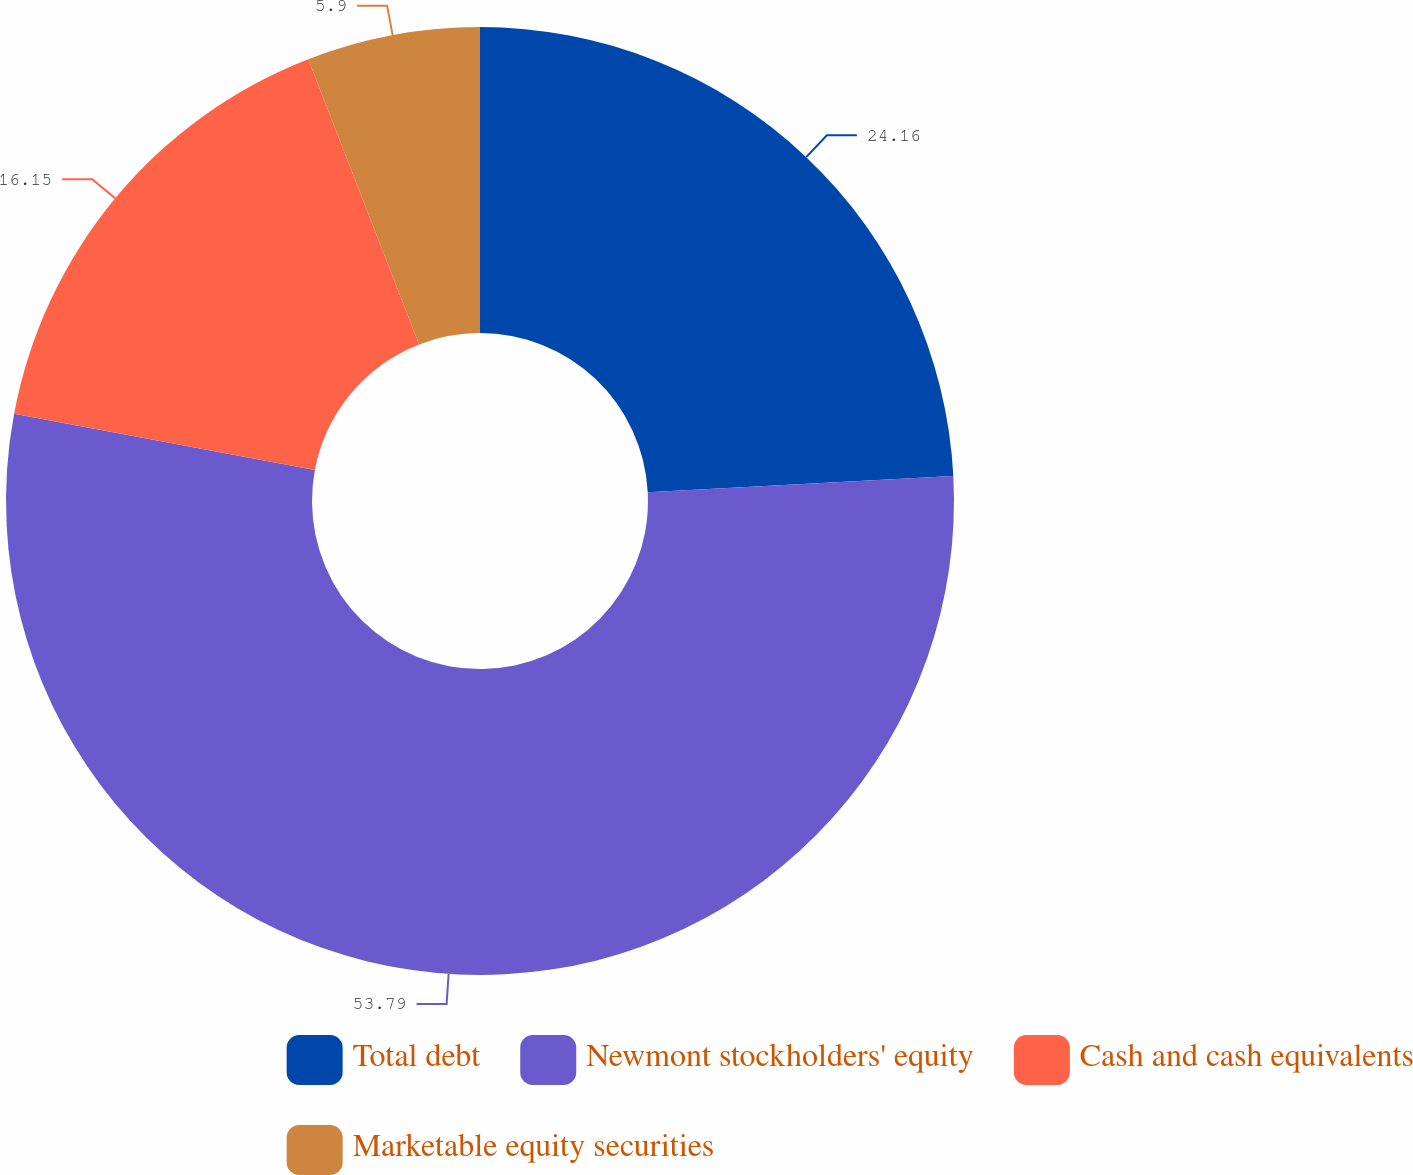<chart> <loc_0><loc_0><loc_500><loc_500><pie_chart><fcel>Total debt<fcel>Newmont stockholders' equity<fcel>Cash and cash equivalents<fcel>Marketable equity securities<nl><fcel>24.16%<fcel>53.78%<fcel>16.15%<fcel>5.9%<nl></chart> 